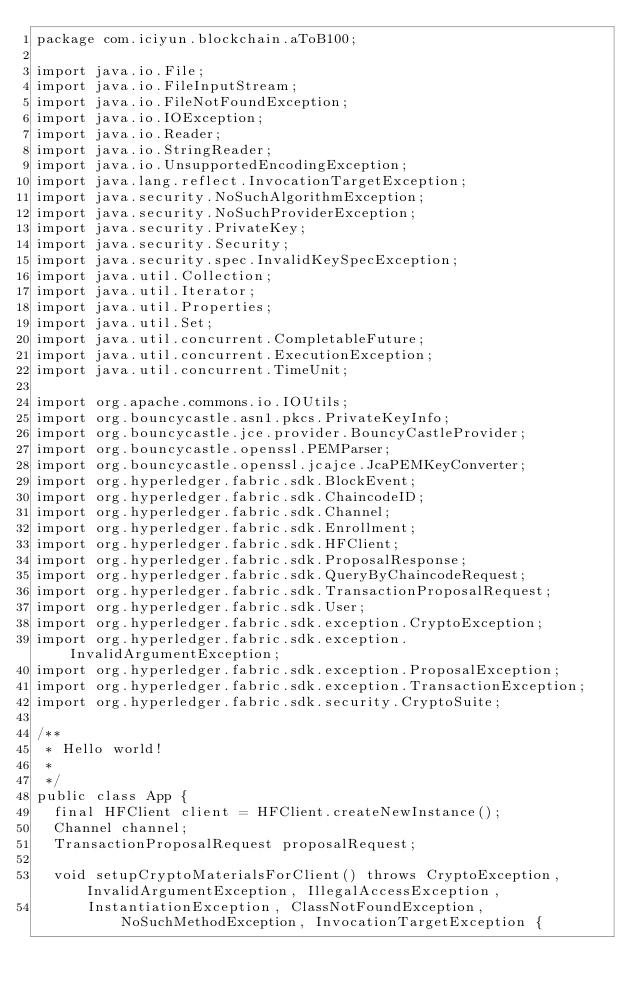<code> <loc_0><loc_0><loc_500><loc_500><_Java_>package com.iciyun.blockchain.aToB100;

import java.io.File;
import java.io.FileInputStream;
import java.io.FileNotFoundException;
import java.io.IOException;
import java.io.Reader;
import java.io.StringReader;
import java.io.UnsupportedEncodingException;
import java.lang.reflect.InvocationTargetException;
import java.security.NoSuchAlgorithmException;
import java.security.NoSuchProviderException;
import java.security.PrivateKey;
import java.security.Security;
import java.security.spec.InvalidKeySpecException;
import java.util.Collection;
import java.util.Iterator;
import java.util.Properties;
import java.util.Set;
import java.util.concurrent.CompletableFuture;
import java.util.concurrent.ExecutionException;
import java.util.concurrent.TimeUnit;

import org.apache.commons.io.IOUtils;
import org.bouncycastle.asn1.pkcs.PrivateKeyInfo;
import org.bouncycastle.jce.provider.BouncyCastleProvider;
import org.bouncycastle.openssl.PEMParser;
import org.bouncycastle.openssl.jcajce.JcaPEMKeyConverter;
import org.hyperledger.fabric.sdk.BlockEvent;
import org.hyperledger.fabric.sdk.ChaincodeID;
import org.hyperledger.fabric.sdk.Channel;
import org.hyperledger.fabric.sdk.Enrollment;
import org.hyperledger.fabric.sdk.HFClient;
import org.hyperledger.fabric.sdk.ProposalResponse;
import org.hyperledger.fabric.sdk.QueryByChaincodeRequest;
import org.hyperledger.fabric.sdk.TransactionProposalRequest;
import org.hyperledger.fabric.sdk.User;
import org.hyperledger.fabric.sdk.exception.CryptoException;
import org.hyperledger.fabric.sdk.exception.InvalidArgumentException;
import org.hyperledger.fabric.sdk.exception.ProposalException;
import org.hyperledger.fabric.sdk.exception.TransactionException;
import org.hyperledger.fabric.sdk.security.CryptoSuite;

/**
 * Hello world!
 *
 */
public class App {
	final HFClient client = HFClient.createNewInstance();
	Channel channel;
	TransactionProposalRequest proposalRequest;

	void setupCryptoMaterialsForClient() throws CryptoException, InvalidArgumentException, IllegalAccessException,
			InstantiationException, ClassNotFoundException, NoSuchMethodException, InvocationTargetException {</code> 